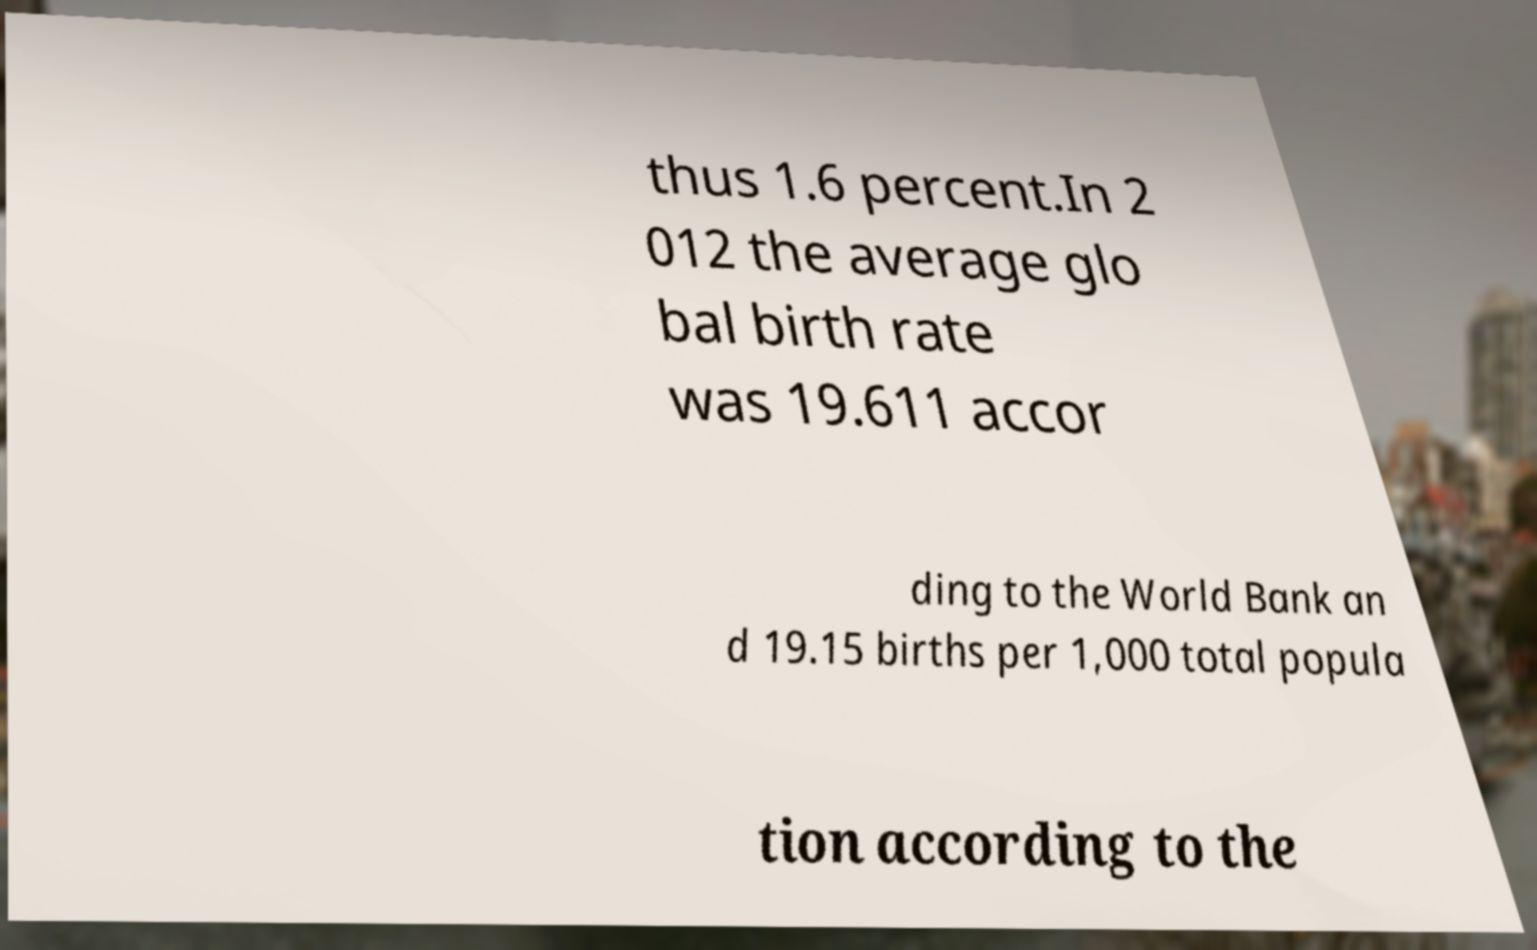For documentation purposes, I need the text within this image transcribed. Could you provide that? thus 1.6 percent.In 2 012 the average glo bal birth rate was 19.611 accor ding to the World Bank an d 19.15 births per 1,000 total popula tion according to the 